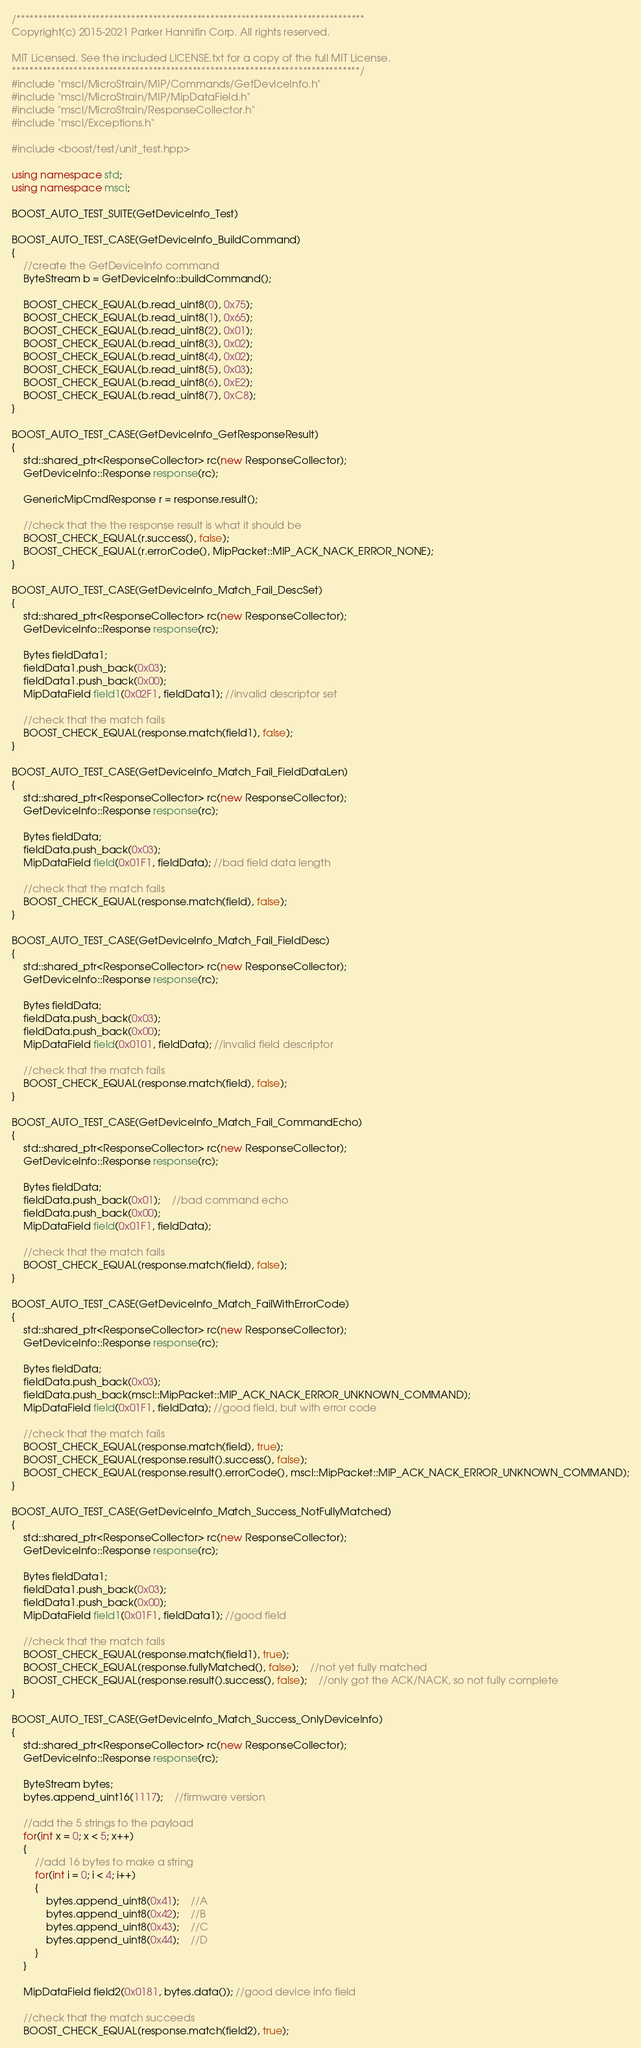<code> <loc_0><loc_0><loc_500><loc_500><_C++_>/*******************************************************************************
Copyright(c) 2015-2021 Parker Hannifin Corp. All rights reserved.

MIT Licensed. See the included LICENSE.txt for a copy of the full MIT License.
*******************************************************************************/
#include "mscl/MicroStrain/MIP/Commands/GetDeviceInfo.h"
#include "mscl/MicroStrain/MIP/MipDataField.h"
#include "mscl/MicroStrain/ResponseCollector.h"
#include "mscl/Exceptions.h"

#include <boost/test/unit_test.hpp>

using namespace std;
using namespace mscl;

BOOST_AUTO_TEST_SUITE(GetDeviceInfo_Test)

BOOST_AUTO_TEST_CASE(GetDeviceInfo_BuildCommand)
{
    //create the GetDeviceInfo command
    ByteStream b = GetDeviceInfo::buildCommand();

    BOOST_CHECK_EQUAL(b.read_uint8(0), 0x75);
    BOOST_CHECK_EQUAL(b.read_uint8(1), 0x65);
    BOOST_CHECK_EQUAL(b.read_uint8(2), 0x01);
    BOOST_CHECK_EQUAL(b.read_uint8(3), 0x02);
    BOOST_CHECK_EQUAL(b.read_uint8(4), 0x02);
    BOOST_CHECK_EQUAL(b.read_uint8(5), 0x03);
    BOOST_CHECK_EQUAL(b.read_uint8(6), 0xE2);
    BOOST_CHECK_EQUAL(b.read_uint8(7), 0xC8);
}

BOOST_AUTO_TEST_CASE(GetDeviceInfo_GetResponseResult)
{
    std::shared_ptr<ResponseCollector> rc(new ResponseCollector);
    GetDeviceInfo::Response response(rc);

    GenericMipCmdResponse r = response.result();

    //check that the the response result is what it should be
    BOOST_CHECK_EQUAL(r.success(), false);
    BOOST_CHECK_EQUAL(r.errorCode(), MipPacket::MIP_ACK_NACK_ERROR_NONE);
}

BOOST_AUTO_TEST_CASE(GetDeviceInfo_Match_Fail_DescSet)
{
    std::shared_ptr<ResponseCollector> rc(new ResponseCollector);
    GetDeviceInfo::Response response(rc);

    Bytes fieldData1;
    fieldData1.push_back(0x03);
    fieldData1.push_back(0x00);
    MipDataField field1(0x02F1, fieldData1); //invalid descriptor set

    //check that the match fails
    BOOST_CHECK_EQUAL(response.match(field1), false);
}

BOOST_AUTO_TEST_CASE(GetDeviceInfo_Match_Fail_FieldDataLen)
{
    std::shared_ptr<ResponseCollector> rc(new ResponseCollector);
    GetDeviceInfo::Response response(rc);

    Bytes fieldData;
    fieldData.push_back(0x03);
    MipDataField field(0x01F1, fieldData); //bad field data length

    //check that the match fails
    BOOST_CHECK_EQUAL(response.match(field), false);
}

BOOST_AUTO_TEST_CASE(GetDeviceInfo_Match_Fail_FieldDesc)
{
    std::shared_ptr<ResponseCollector> rc(new ResponseCollector);
    GetDeviceInfo::Response response(rc);

    Bytes fieldData;
    fieldData.push_back(0x03);
    fieldData.push_back(0x00);
    MipDataField field(0x0101, fieldData); //invalid field descriptor

    //check that the match fails
    BOOST_CHECK_EQUAL(response.match(field), false);
}

BOOST_AUTO_TEST_CASE(GetDeviceInfo_Match_Fail_CommandEcho)
{
    std::shared_ptr<ResponseCollector> rc(new ResponseCollector);
    GetDeviceInfo::Response response(rc);

    Bytes fieldData;
    fieldData.push_back(0x01);    //bad command echo
    fieldData.push_back(0x00);
    MipDataField field(0x01F1, fieldData);

    //check that the match fails
    BOOST_CHECK_EQUAL(response.match(field), false);
}

BOOST_AUTO_TEST_CASE(GetDeviceInfo_Match_FailWithErrorCode)
{
    std::shared_ptr<ResponseCollector> rc(new ResponseCollector);
    GetDeviceInfo::Response response(rc);

    Bytes fieldData;
    fieldData.push_back(0x03);
    fieldData.push_back(mscl::MipPacket::MIP_ACK_NACK_ERROR_UNKNOWN_COMMAND);
    MipDataField field(0x01F1, fieldData); //good field, but with error code

    //check that the match fails
    BOOST_CHECK_EQUAL(response.match(field), true);
    BOOST_CHECK_EQUAL(response.result().success(), false);
    BOOST_CHECK_EQUAL(response.result().errorCode(), mscl::MipPacket::MIP_ACK_NACK_ERROR_UNKNOWN_COMMAND);
}

BOOST_AUTO_TEST_CASE(GetDeviceInfo_Match_Success_NotFullyMatched)
{
    std::shared_ptr<ResponseCollector> rc(new ResponseCollector);
    GetDeviceInfo::Response response(rc);

    Bytes fieldData1;
    fieldData1.push_back(0x03);
    fieldData1.push_back(0x00);
    MipDataField field1(0x01F1, fieldData1); //good field

    //check that the match fails
    BOOST_CHECK_EQUAL(response.match(field1), true);
    BOOST_CHECK_EQUAL(response.fullyMatched(), false);    //not yet fully matched
    BOOST_CHECK_EQUAL(response.result().success(), false);    //only got the ACK/NACK, so not fully complete
}

BOOST_AUTO_TEST_CASE(GetDeviceInfo_Match_Success_OnlyDeviceInfo)
{
    std::shared_ptr<ResponseCollector> rc(new ResponseCollector);
    GetDeviceInfo::Response response(rc);

    ByteStream bytes;
    bytes.append_uint16(1117);    //firmware version
    
    //add the 5 strings to the payload
    for(int x = 0; x < 5; x++)
    {
        //add 16 bytes to make a string
        for(int i = 0; i < 4; i++)
        {
            bytes.append_uint8(0x41);    //A
            bytes.append_uint8(0x42);    //B
            bytes.append_uint8(0x43);    //C
            bytes.append_uint8(0x44);    //D
        }
    }

    MipDataField field2(0x0181, bytes.data()); //good device info field

    //check that the match succeeds
    BOOST_CHECK_EQUAL(response.match(field2), true); </code> 